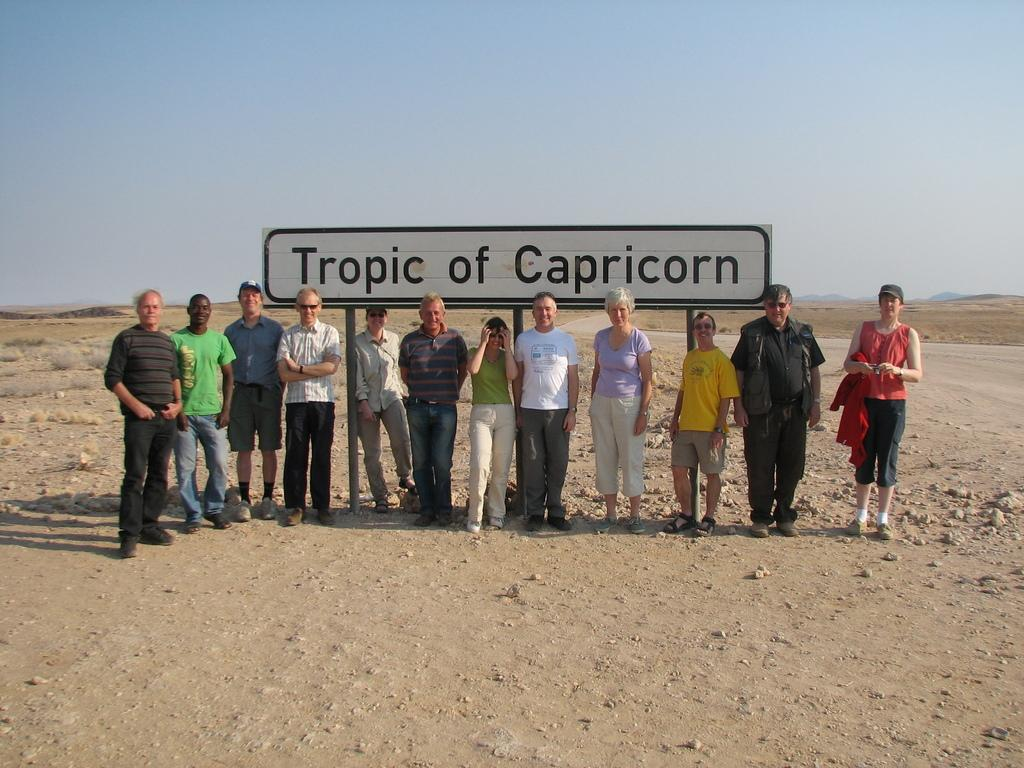What are the people in the image doing? There is a group of people standing on the ground in the image. What can be seen near the group of people? There is a name board in the image. What type of natural elements are present in the image? Stones and plants are visible in the image. What can be seen in the distance in the image? There are mountains in the background of the image, and the sky is visible as well. What type of muscle is being flexed by the people in the image? There is no indication in the image that the people are flexing any muscles. 